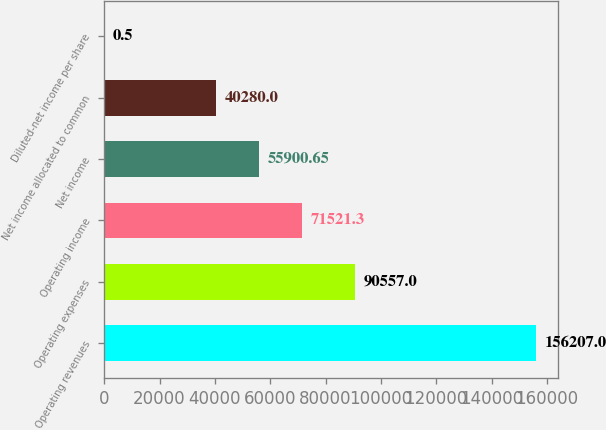Convert chart. <chart><loc_0><loc_0><loc_500><loc_500><bar_chart><fcel>Operating revenues<fcel>Operating expenses<fcel>Operating income<fcel>Net income<fcel>Net income allocated to common<fcel>Diluted-net income per share<nl><fcel>156207<fcel>90557<fcel>71521.3<fcel>55900.7<fcel>40280<fcel>0.5<nl></chart> 